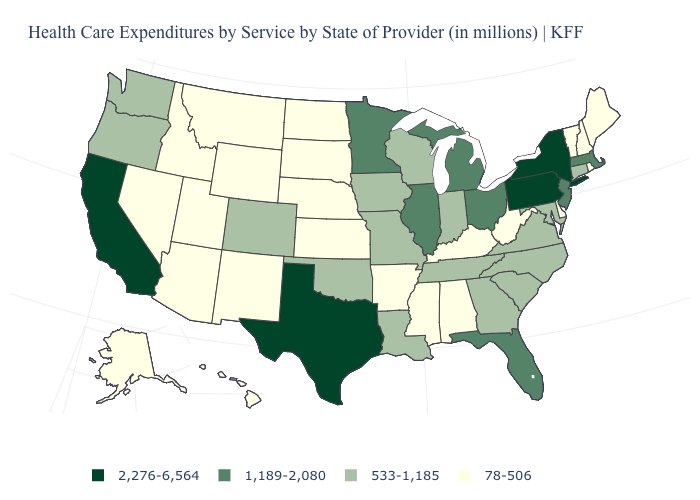What is the value of Maryland?
Answer briefly. 533-1,185. How many symbols are there in the legend?
Concise answer only. 4. What is the lowest value in the USA?
Answer briefly. 78-506. Name the states that have a value in the range 533-1,185?
Keep it brief. Colorado, Connecticut, Georgia, Indiana, Iowa, Louisiana, Maryland, Missouri, North Carolina, Oklahoma, Oregon, South Carolina, Tennessee, Virginia, Washington, Wisconsin. Among the states that border Florida , does Georgia have the highest value?
Give a very brief answer. Yes. Does the first symbol in the legend represent the smallest category?
Give a very brief answer. No. Does Connecticut have the same value as Indiana?
Short answer required. Yes. What is the value of Washington?
Write a very short answer. 533-1,185. What is the lowest value in the USA?
Short answer required. 78-506. Does South Carolina have a lower value than Virginia?
Answer briefly. No. Which states have the highest value in the USA?
Short answer required. California, New York, Pennsylvania, Texas. What is the value of Wyoming?
Quick response, please. 78-506. Does Minnesota have the lowest value in the USA?
Give a very brief answer. No. What is the value of Pennsylvania?
Answer briefly. 2,276-6,564. What is the value of Alabama?
Concise answer only. 78-506. 